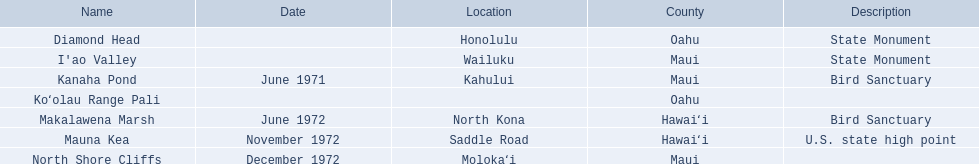What are all of the landmark names in hawaii? Diamond Head, I'ao Valley, Kanaha Pond, Koʻolau Range Pali, Makalawena Marsh, Mauna Kea, North Shore Cliffs. What are their descriptions? State Monument, State Monument, Bird Sanctuary, , Bird Sanctuary, U.S. state high point, . And which is described as a u.s. state high point? Mauna Kea. 